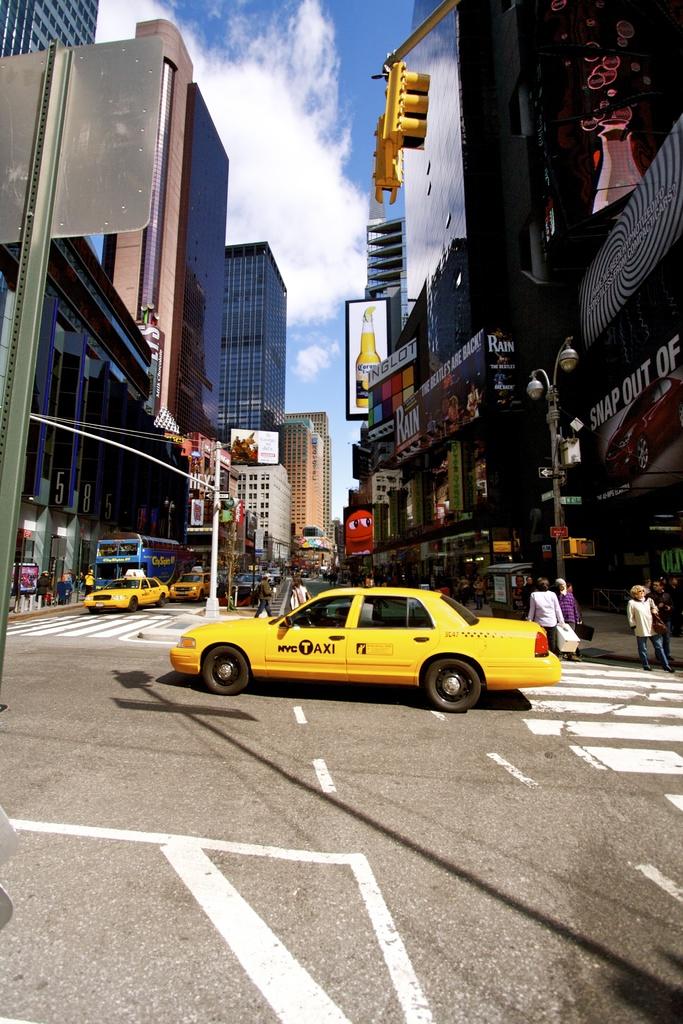What city is the taxi from?
Give a very brief answer. New york city. What kind of beer is the ad showing?
Your answer should be very brief. Corona. 